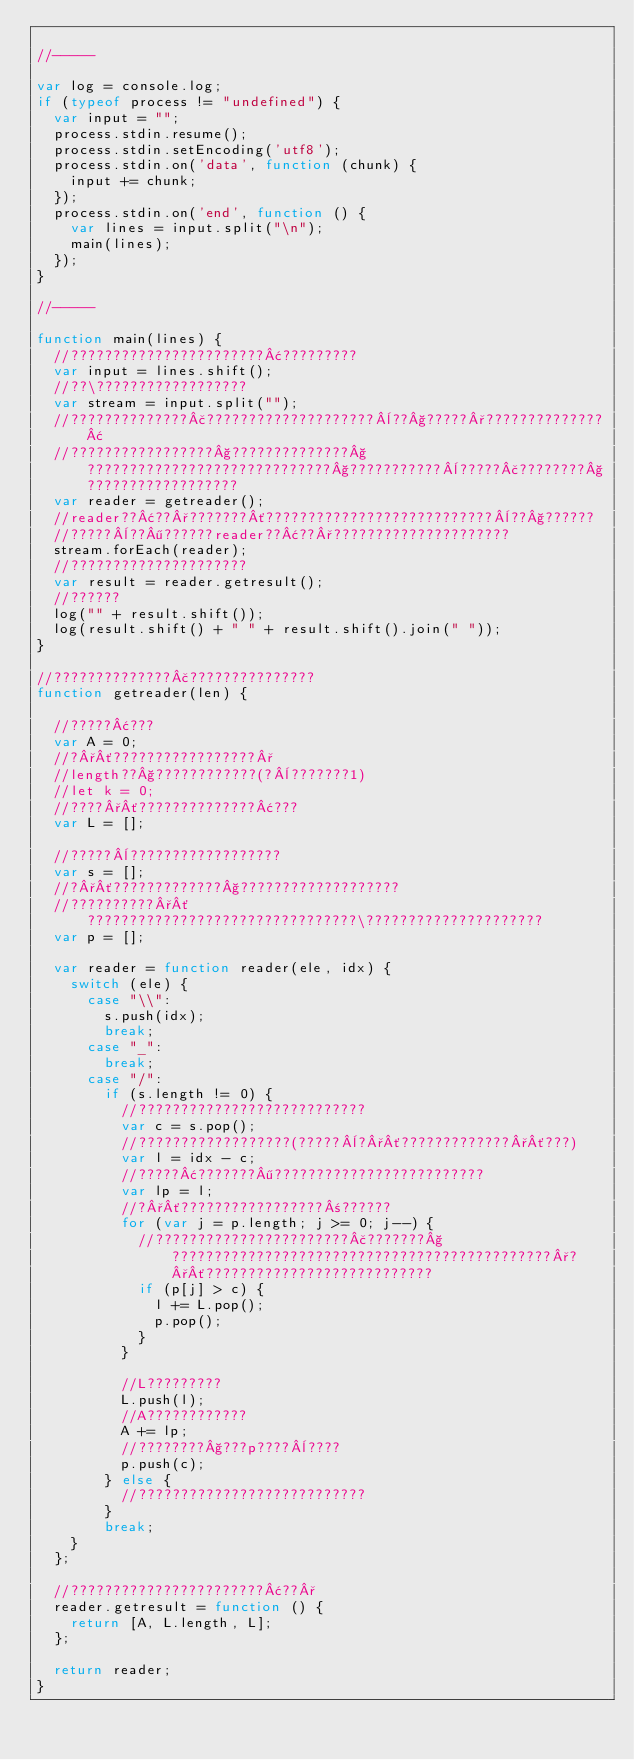Convert code to text. <code><loc_0><loc_0><loc_500><loc_500><_JavaScript_>
//-----

var log = console.log;
if (typeof process != "undefined") {
	var input = "";
	process.stdin.resume();
	process.stdin.setEncoding('utf8');
	process.stdin.on('data', function (chunk) {
		input += chunk;
	});
	process.stdin.on('end', function () {
		var lines = input.split("\n");
		main(lines);
	});
}

//-----

function main(lines) {
	//???????????????????????¢?????????
	var input = lines.shift();
	//??\??????????????????
	var stream = input.split("");
	//??????????????£????????????????????¨??§?????°??????????????¢
	//?????????????????§??????????????§?????????????????????????????§???????????¨?????£????????§??????????????????
	var reader = getreader();
	//reader??¢??°???????´???????????????????????????¨??§??????
	//?????¨??¶??????reader??¢??°?????????????????????
	stream.forEach(reader);
	//?????????????????????
	var result = reader.getresult();
	//??????
	log("" + result.shift());
	log(result.shift() + " " + result.shift().join(" "));
}

//??????????????£???????????????
function getreader(len) {

	//?????¢???
	var A = 0;
	//?°´?????????????????°
	//length??§????????????(?¨???????1)
	//let k = 0;
	//????°´??????????????¢???
	var L = [];

	//?????¨??????????????????
	var s = [];
	//?°´?????????????§???????????????????
	//??????????°´????????????????????????????????\?????????????????????
	var p = [];

	var reader = function reader(ele, idx) {
		switch (ele) {
			case "\\":
				s.push(idx);
				break;
			case "_":
				break;
			case "/":
				if (s.length != 0) {
					//???????????????????????????
					var c = s.pop();
					//??????????????????(?????¨?°´?????????????°´???)
					var l = idx - c;
					//?????¢???????¶?????????????????????????
					var lp = l;
					//?°´?????????????????±??????
					for (var j = p.length; j >= 0; j--) {
						//???????????????????????£???????§?????????????????????????????????????????????°?°´???????????????????????????
						if (p[j] > c) {
							l += L.pop();
							p.pop();
						}
					}

					//L?????????
					L.push(l);
					//A????????????
					A += lp;
					//????????§???p????¨????
					p.push(c);
				} else {
					//???????????????????????????
				}
				break;
		}
	};

	//???????????????????????¢??°
	reader.getresult = function () {
		return [A, L.length, L];
	};

	return reader;
}</code> 